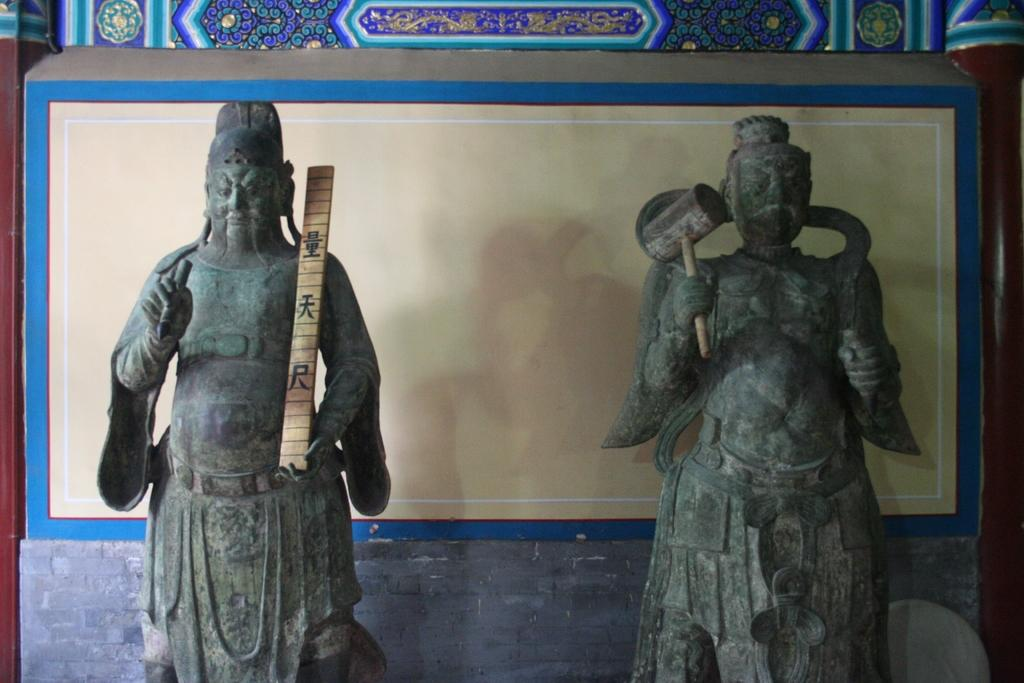What type of objects can be seen in the image? There are sculptures in the image. How many sculptures are visible in the image? There are at least two sculptures in the image. What type of comfort can be seen in the image? There is no reference to comfort in the image; it features sculptures. What type of bread is visible in the image? There is no bread or loaf present in the image. 